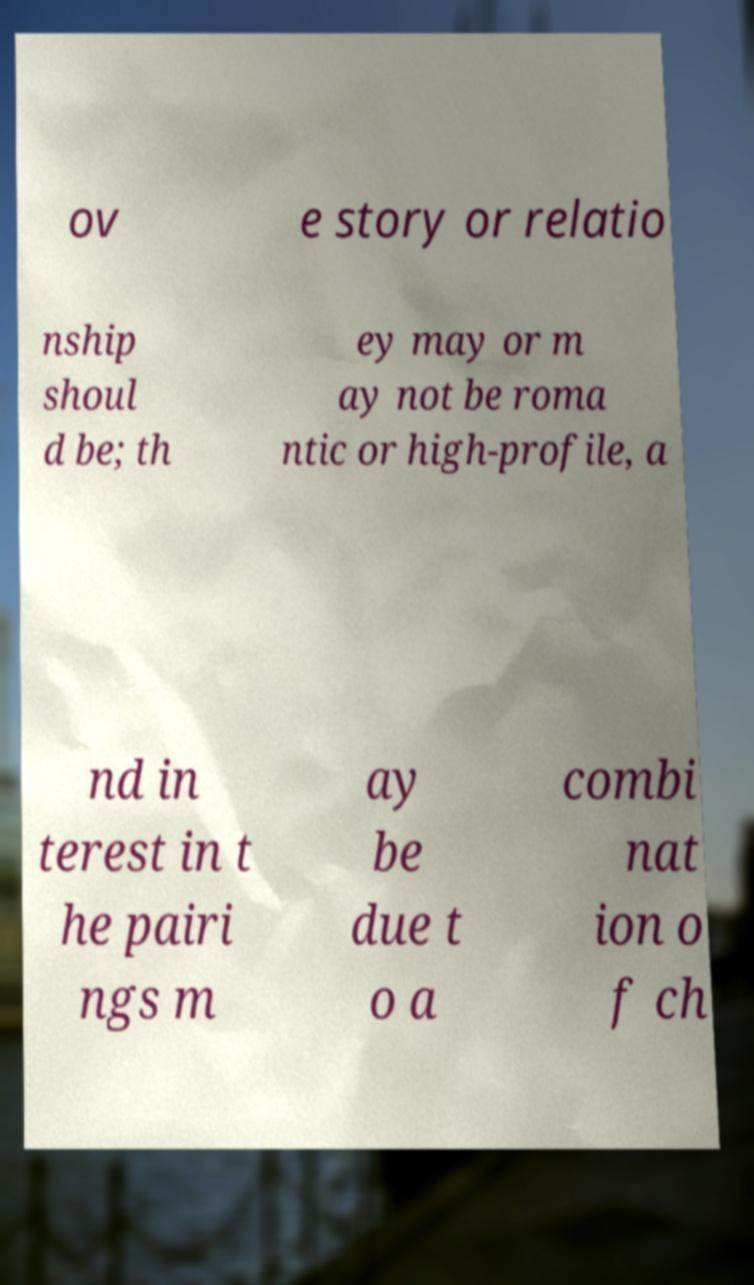Can you read and provide the text displayed in the image?This photo seems to have some interesting text. Can you extract and type it out for me? ov e story or relatio nship shoul d be; th ey may or m ay not be roma ntic or high-profile, a nd in terest in t he pairi ngs m ay be due t o a combi nat ion o f ch 